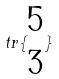<formula> <loc_0><loc_0><loc_500><loc_500>t r \{ \begin{matrix} 5 \\ 3 \end{matrix} \}</formula> 